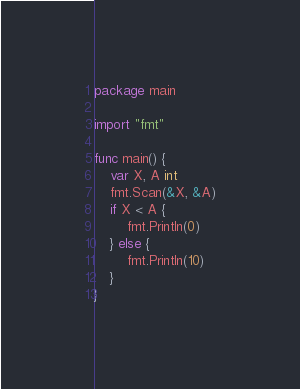<code> <loc_0><loc_0><loc_500><loc_500><_Go_>package main

import "fmt"

func main() {
	var X, A int
	fmt.Scan(&X, &A)
	if X < A {
		fmt.Println(0)
	} else {
		fmt.Println(10)
	}
}
</code> 